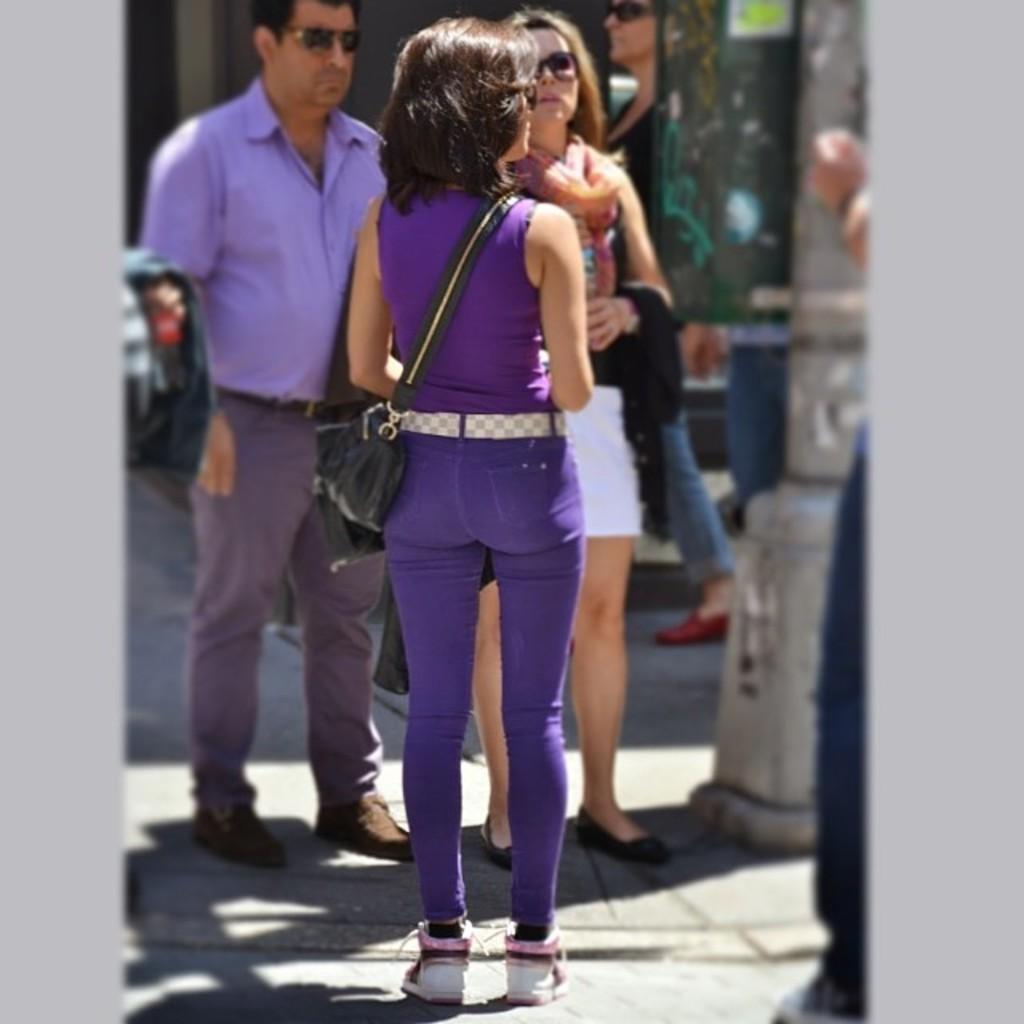In one or two sentences, can you explain what this image depicts? In this picture I can see a woman standing, and in the background there are few people standing and there are some objects. 